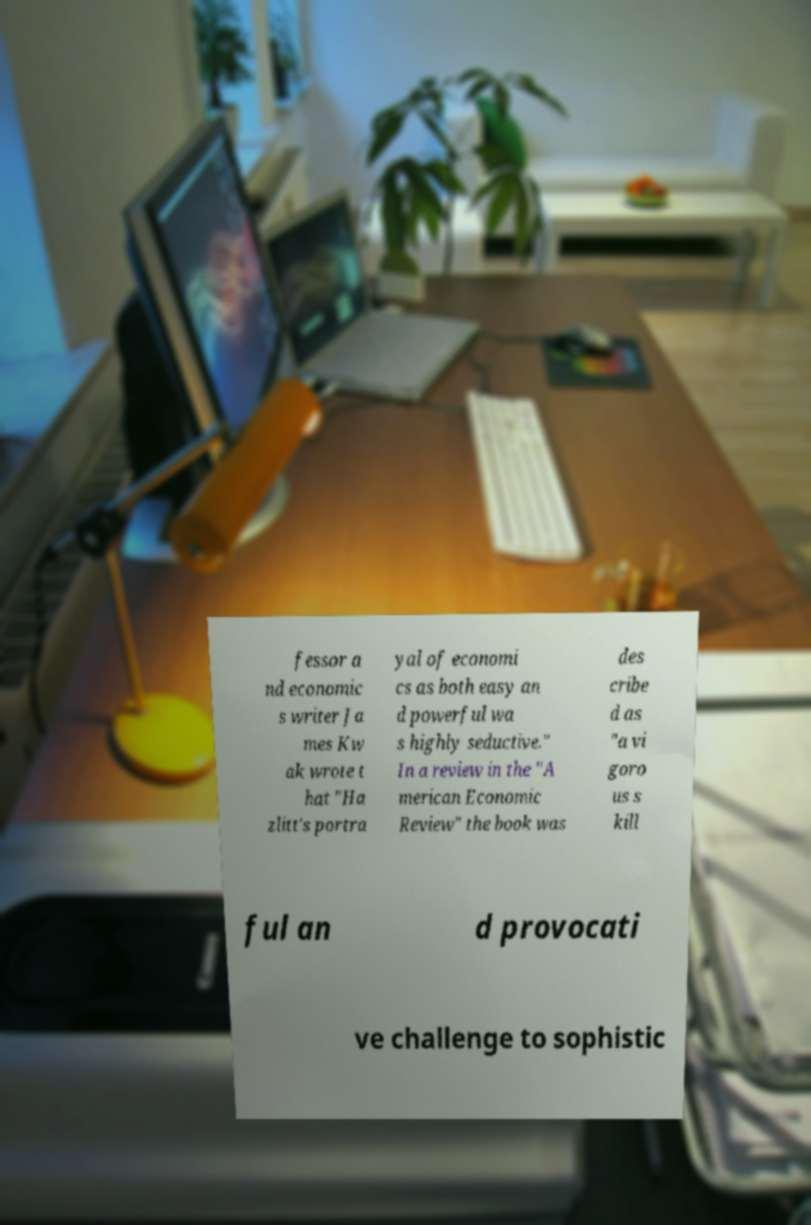Please identify and transcribe the text found in this image. fessor a nd economic s writer Ja mes Kw ak wrote t hat "Ha zlitt's portra yal of economi cs as both easy an d powerful wa s highly seductive." In a review in the "A merican Economic Review" the book was des cribe d as "a vi goro us s kill ful an d provocati ve challenge to sophistic 